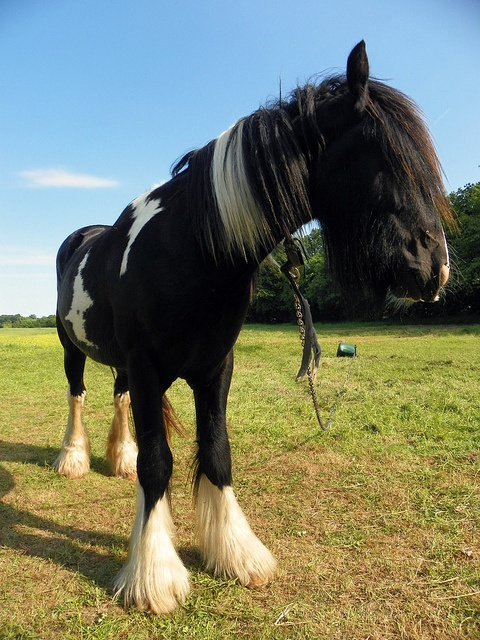Describe the objects in this image and their specific colors. I can see a horse in gray, black, olive, and tan tones in this image. 